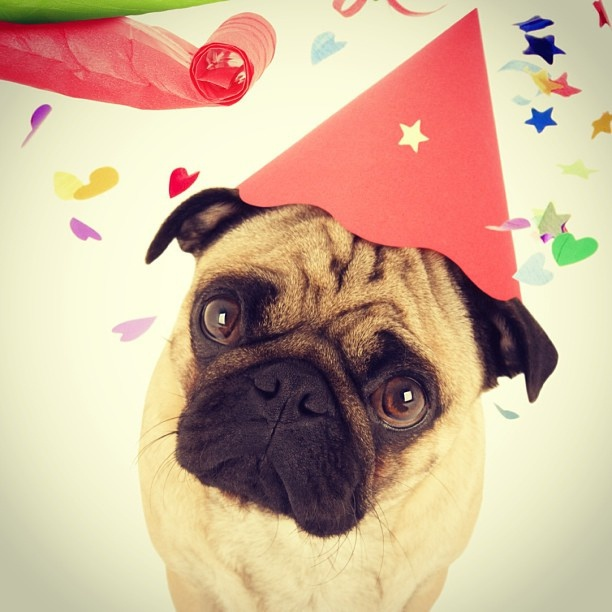Describe the objects in this image and their specific colors. I can see a dog in olive, khaki, black, tan, and maroon tones in this image. 